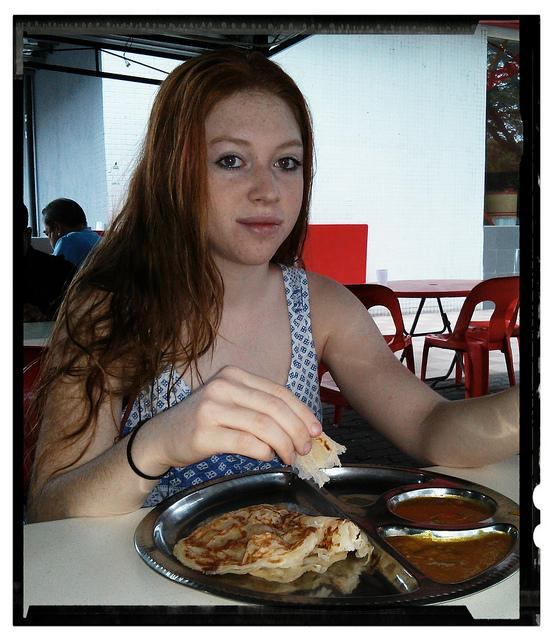What kind of bread is this? Please explain your reasoning. naan. It's naan bread 